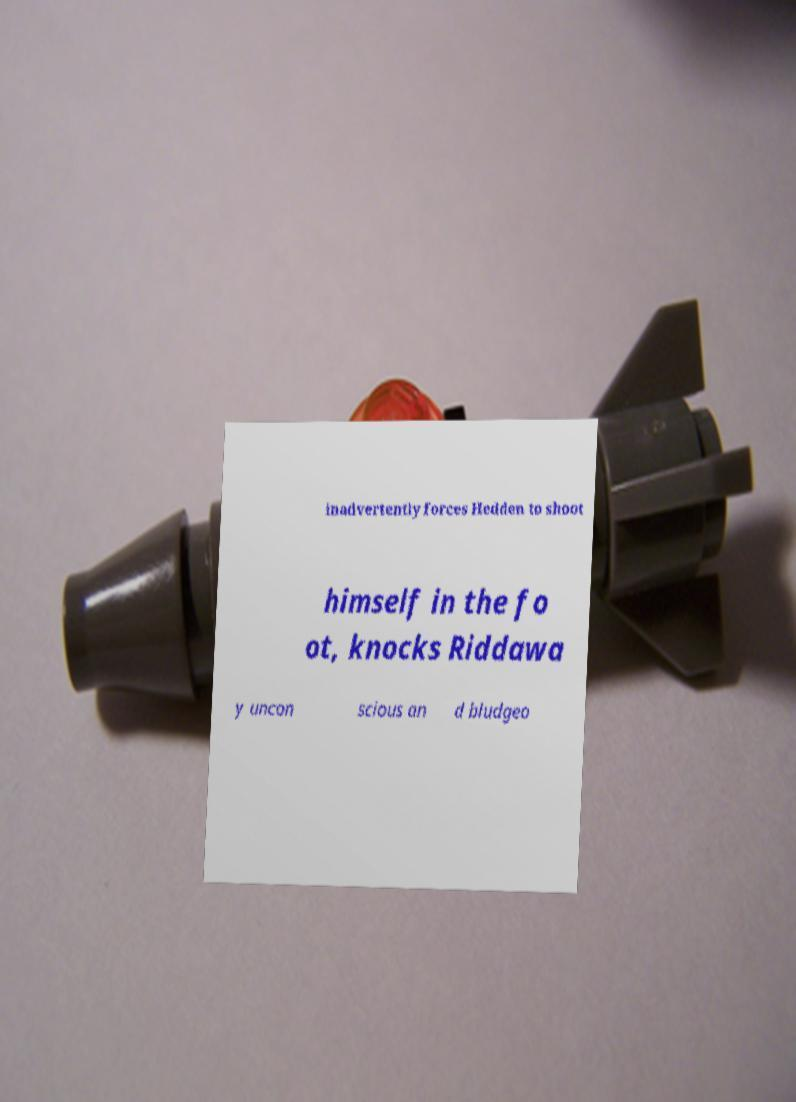There's text embedded in this image that I need extracted. Can you transcribe it verbatim? inadvertently forces Hedden to shoot himself in the fo ot, knocks Riddawa y uncon scious an d bludgeo 